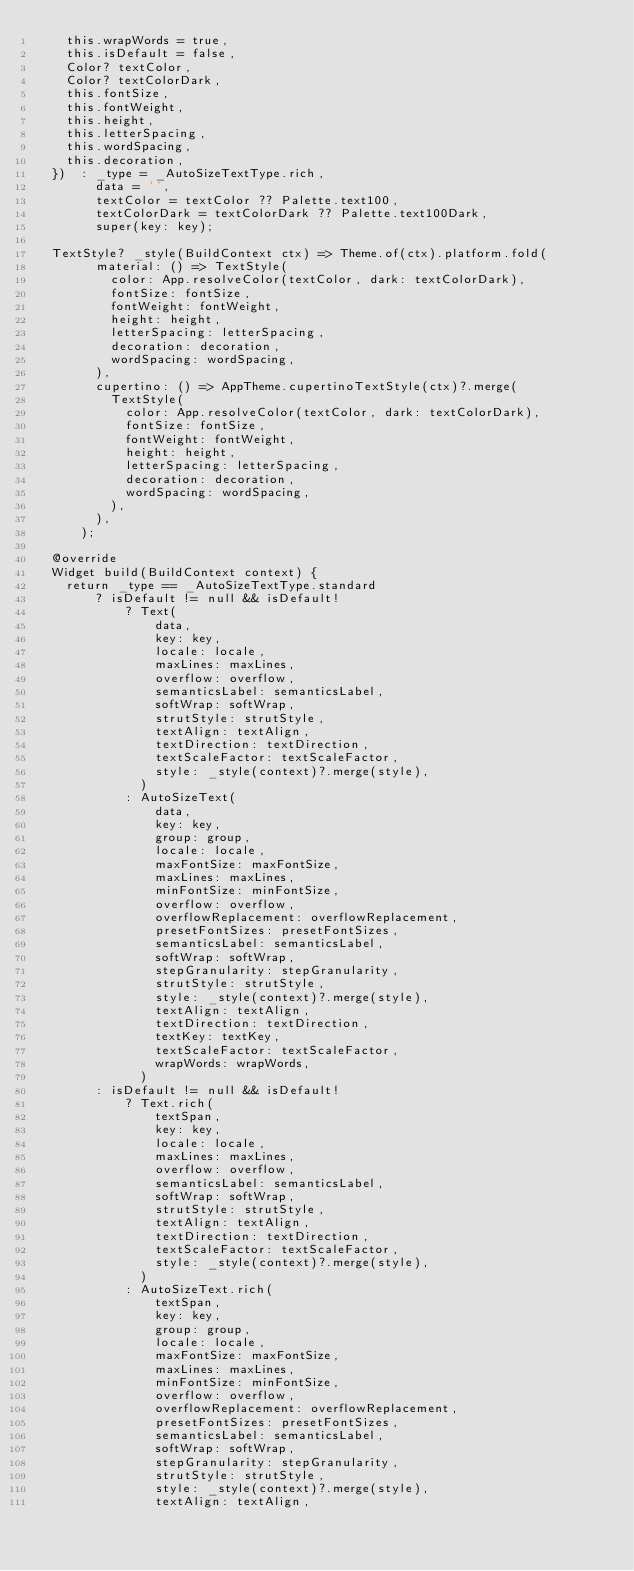Convert code to text. <code><loc_0><loc_0><loc_500><loc_500><_Dart_>    this.wrapWords = true,
    this.isDefault = false,
    Color? textColor,
    Color? textColorDark,
    this.fontSize,
    this.fontWeight,
    this.height,
    this.letterSpacing,
    this.wordSpacing,
    this.decoration,
  })  : _type = _AutoSizeTextType.rich,
        data = '',
        textColor = textColor ?? Palette.text100,
        textColorDark = textColorDark ?? Palette.text100Dark,
        super(key: key);

  TextStyle? _style(BuildContext ctx) => Theme.of(ctx).platform.fold(
        material: () => TextStyle(
          color: App.resolveColor(textColor, dark: textColorDark),
          fontSize: fontSize,
          fontWeight: fontWeight,
          height: height,
          letterSpacing: letterSpacing,
          decoration: decoration,
          wordSpacing: wordSpacing,
        ),
        cupertino: () => AppTheme.cupertinoTextStyle(ctx)?.merge(
          TextStyle(
            color: App.resolveColor(textColor, dark: textColorDark),
            fontSize: fontSize,
            fontWeight: fontWeight,
            height: height,
            letterSpacing: letterSpacing,
            decoration: decoration,
            wordSpacing: wordSpacing,
          ),
        ),
      );

  @override
  Widget build(BuildContext context) {
    return _type == _AutoSizeTextType.standard
        ? isDefault != null && isDefault!
            ? Text(
                data,
                key: key,
                locale: locale,
                maxLines: maxLines,
                overflow: overflow,
                semanticsLabel: semanticsLabel,
                softWrap: softWrap,
                strutStyle: strutStyle,
                textAlign: textAlign,
                textDirection: textDirection,
                textScaleFactor: textScaleFactor,
                style: _style(context)?.merge(style),
              )
            : AutoSizeText(
                data,
                key: key,
                group: group,
                locale: locale,
                maxFontSize: maxFontSize,
                maxLines: maxLines,
                minFontSize: minFontSize,
                overflow: overflow,
                overflowReplacement: overflowReplacement,
                presetFontSizes: presetFontSizes,
                semanticsLabel: semanticsLabel,
                softWrap: softWrap,
                stepGranularity: stepGranularity,
                strutStyle: strutStyle,
                style: _style(context)?.merge(style),
                textAlign: textAlign,
                textDirection: textDirection,
                textKey: textKey,
                textScaleFactor: textScaleFactor,
                wrapWords: wrapWords,
              )
        : isDefault != null && isDefault!
            ? Text.rich(
                textSpan,
                key: key,
                locale: locale,
                maxLines: maxLines,
                overflow: overflow,
                semanticsLabel: semanticsLabel,
                softWrap: softWrap,
                strutStyle: strutStyle,
                textAlign: textAlign,
                textDirection: textDirection,
                textScaleFactor: textScaleFactor,
                style: _style(context)?.merge(style),
              )
            : AutoSizeText.rich(
                textSpan,
                key: key,
                group: group,
                locale: locale,
                maxFontSize: maxFontSize,
                maxLines: maxLines,
                minFontSize: minFontSize,
                overflow: overflow,
                overflowReplacement: overflowReplacement,
                presetFontSizes: presetFontSizes,
                semanticsLabel: semanticsLabel,
                softWrap: softWrap,
                stepGranularity: stepGranularity,
                strutStyle: strutStyle,
                style: _style(context)?.merge(style),
                textAlign: textAlign,</code> 